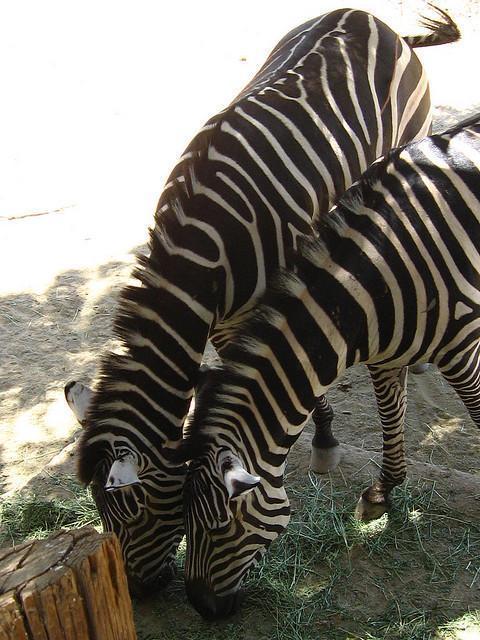How many zebras are in the picture?
Give a very brief answer. 2. 